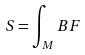Convert formula to latex. <formula><loc_0><loc_0><loc_500><loc_500>S = \int _ { M } B F</formula> 